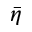<formula> <loc_0><loc_0><loc_500><loc_500>\bar { \eta }</formula> 